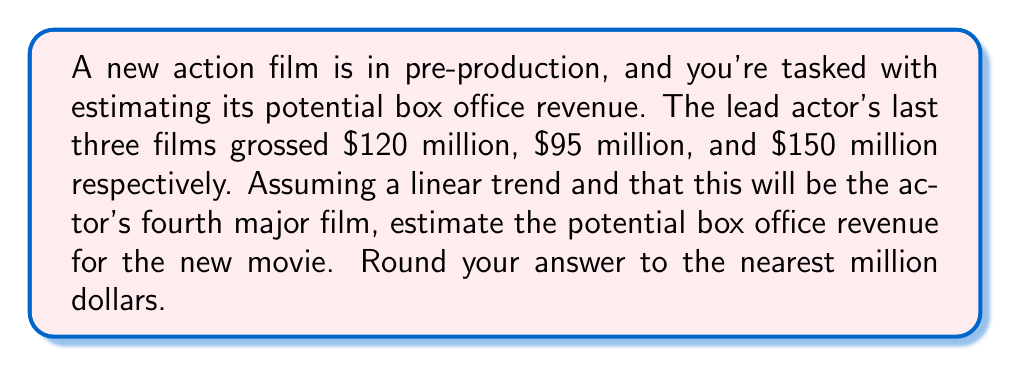Can you solve this math problem? To estimate the potential box office revenue, we'll use a linear regression model based on the actor's previous performance data. Let's follow these steps:

1) First, let's assign x-values to each film:
   Film 1: x = 1, y = $120 million
   Film 2: x = 2, y = $95 million
   Film 3: x = 3, y = $150 million

2) We need to calculate the slope (m) and y-intercept (b) of the linear trend line using the formula:
   $$y = mx + b$$

3) To find the slope (m), we use the formula:
   $$m = \frac{n\sum xy - \sum x \sum y}{n\sum x^2 - (\sum x)^2}$$

   Where n is the number of data points (3 in this case).

4) Let's calculate the necessary sums:
   $$\sum x = 1 + 2 + 3 = 6$$
   $$\sum y = 120 + 95 + 150 = 365$$
   $$\sum xy = (1)(120) + (2)(95) + (3)(150) = 760$$
   $$\sum x^2 = 1^2 + 2^2 + 3^2 = 14$$

5) Now we can calculate the slope:
   $$m = \frac{3(760) - (6)(365)}{3(14) - (6)^2} = \frac{2280 - 2190}{42 - 36} = \frac{90}{6} = 15$$

6) To find the y-intercept (b), we use the formula:
   $$b = \frac{\sum y - m\sum x}{n}$$

   $$b = \frac{365 - 15(6)}{3} = \frac{365 - 90}{3} = 91.67$$

7) Now we have our linear equation:
   $$y = 15x + 91.67$$

8) For the fourth film, x = 4. Let's substitute this into our equation:
   $$y = 15(4) + 91.67 = 60 + 91.67 = 151.67$$

9) Rounding to the nearest million:
   $151.67 million ≈ $152 million
Answer: $152 million 